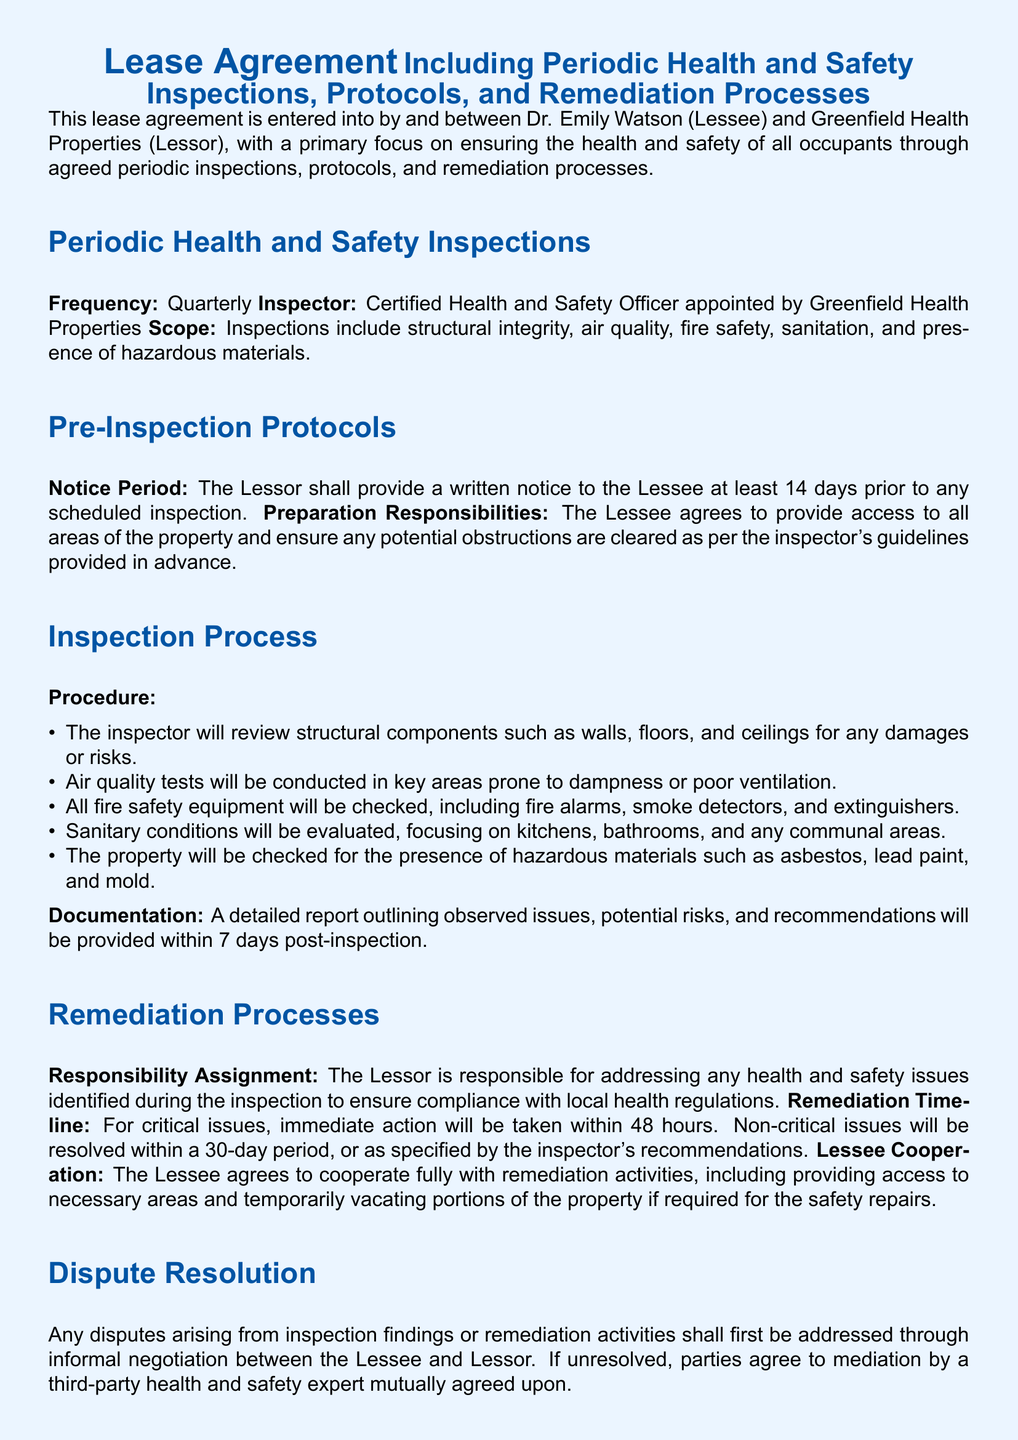What is the frequency of inspections? The frequency of inspections is specified in the document as quarterly.
Answer: Quarterly Who is responsible for remediation processes? The document clearly states that the Lessor is responsible for addressing any health and safety issues identified during the inspection.
Answer: Lessor What must the Lessor provide before an inspection? The document states the Lessor must provide a written notice at least 14 days prior to any scheduled inspection.
Answer: Written notice What is the response time for critical issues? For critical issues identified during inspections, the document specifies that immediate action will be taken within 48 hours.
Answer: 48 hours How long does the inspector have to provide a report? According to the document, a detailed report must be provided within 7 days post-inspection.
Answer: 7 days What types of components are reviewed during inspections? The inspector reviews structural components, air quality, fire safety, sanitation, and hazardous materials.
Answer: Structural components, air quality, fire safety, sanitation, hazardous materials What happens if disputes arise from inspection findings? The document states that any disputes shall first be addressed through informal negotiation.
Answer: Informal negotiation What should the Lessee do to prepare for inspections? The Lessee agrees to provide access to areas and ensure any potential obstructions are cleared as per the inspector's guidelines.
Answer: Provide access and clear obstructions 